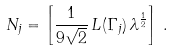<formula> <loc_0><loc_0><loc_500><loc_500>N _ { j } = \left [ \frac { 1 } { 9 \sqrt { 2 } } \, L ( \Gamma _ { j } ) \, \lambda ^ { \frac { 1 } { 2 } } \right ] \, .</formula> 